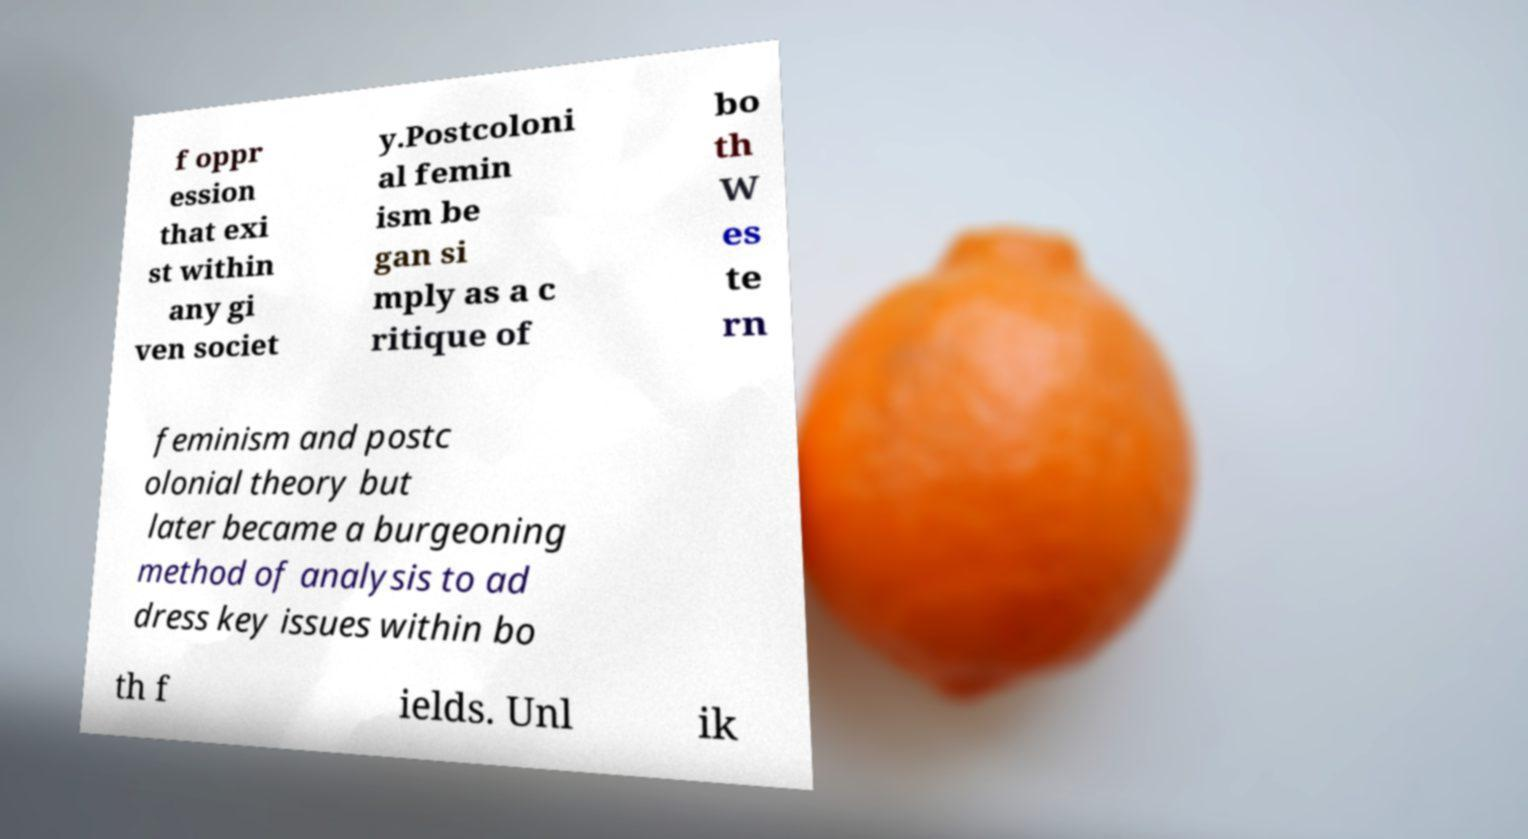There's text embedded in this image that I need extracted. Can you transcribe it verbatim? f oppr ession that exi st within any gi ven societ y.Postcoloni al femin ism be gan si mply as a c ritique of bo th W es te rn feminism and postc olonial theory but later became a burgeoning method of analysis to ad dress key issues within bo th f ields. Unl ik 